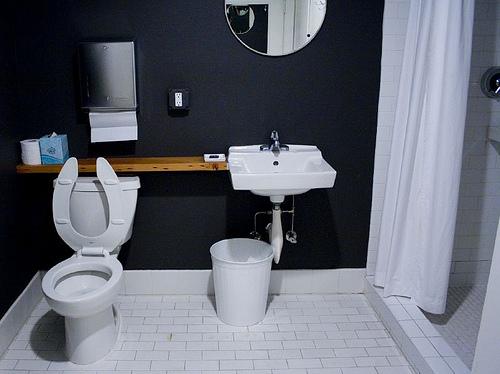Where is the toilet paper?
Write a very short answer. On shelf. How many rolls of toilet paper?
Answer briefly. 1. In what position is the toilet seat?
Give a very brief answer. Up. Where are the extra rolls of toilet paper kept?
Write a very short answer. On shelf. Does the garbage need to be emptied?
Answer briefly. No. What color is the shower curtain in this bathroom?
Keep it brief. White. What is next to the tissue box?
Write a very short answer. Toilet paper. Is the bathroom public?
Write a very short answer. No. Is there graffiti on the wastebasket?
Write a very short answer. No. Is there urine on the floor?
Keep it brief. No. 